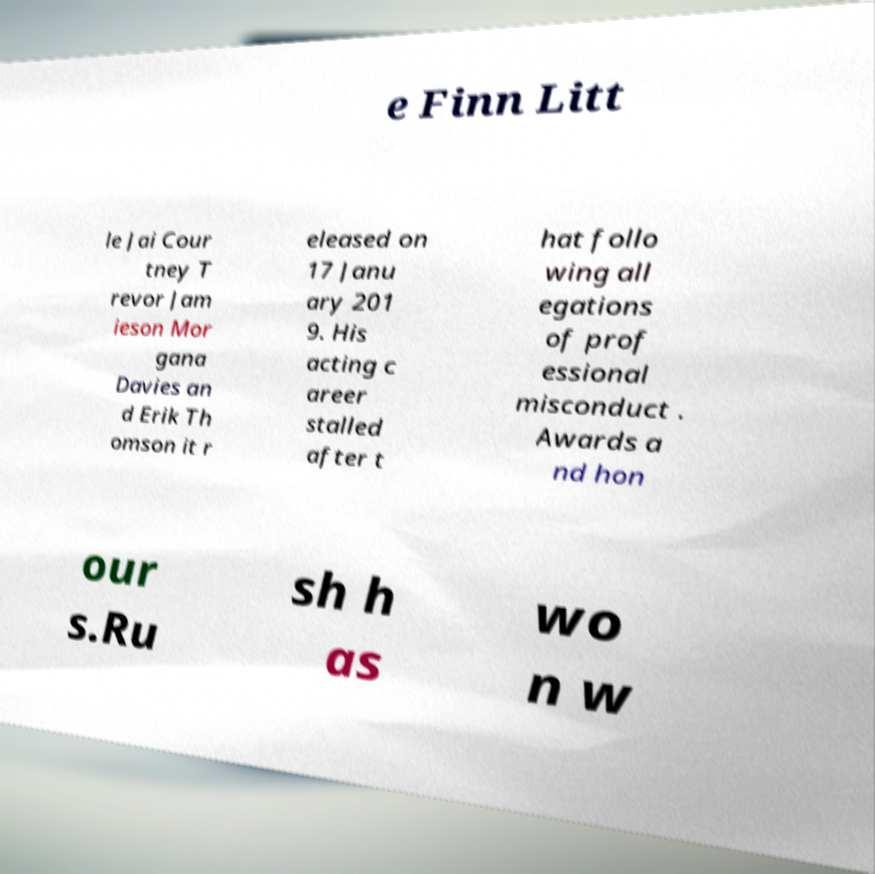There's text embedded in this image that I need extracted. Can you transcribe it verbatim? e Finn Litt le Jai Cour tney T revor Jam ieson Mor gana Davies an d Erik Th omson it r eleased on 17 Janu ary 201 9. His acting c areer stalled after t hat follo wing all egations of prof essional misconduct . Awards a nd hon our s.Ru sh h as wo n w 